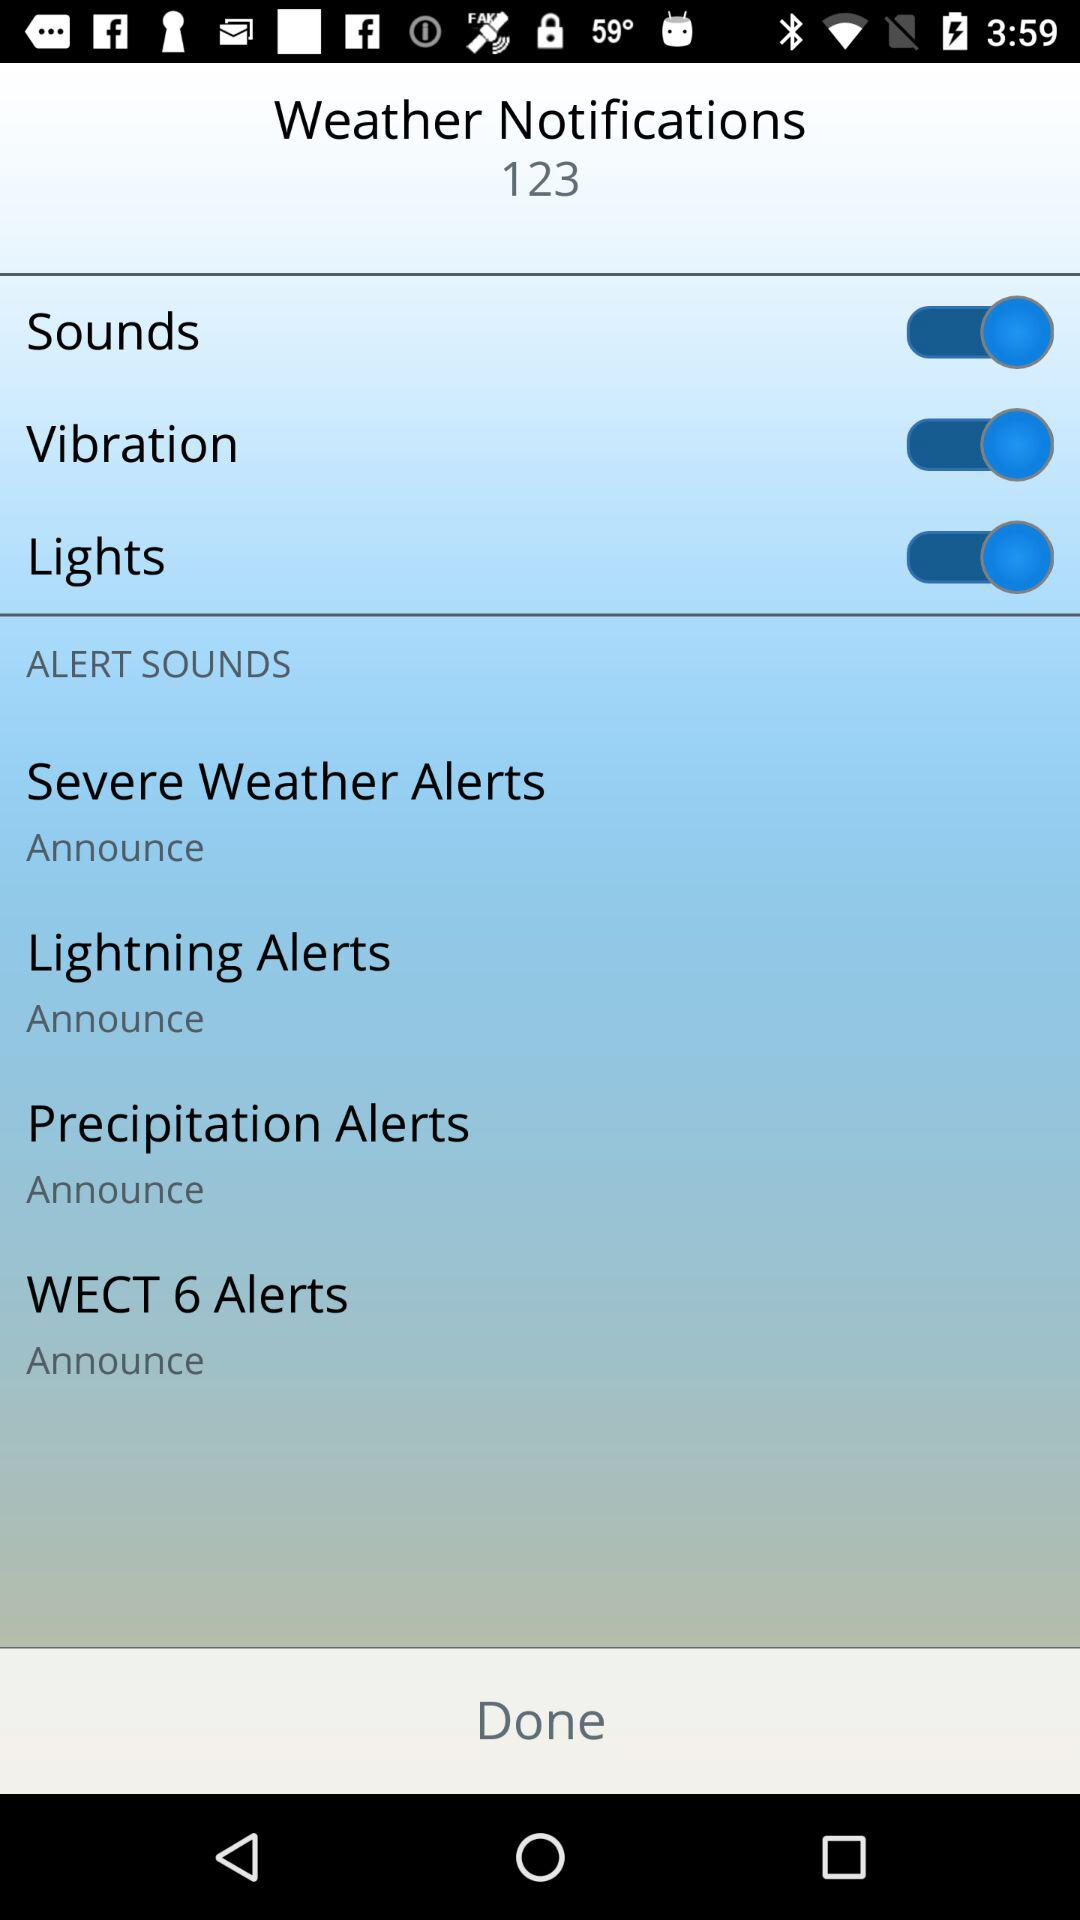What is the status of "Vibration"? The status is "on". 